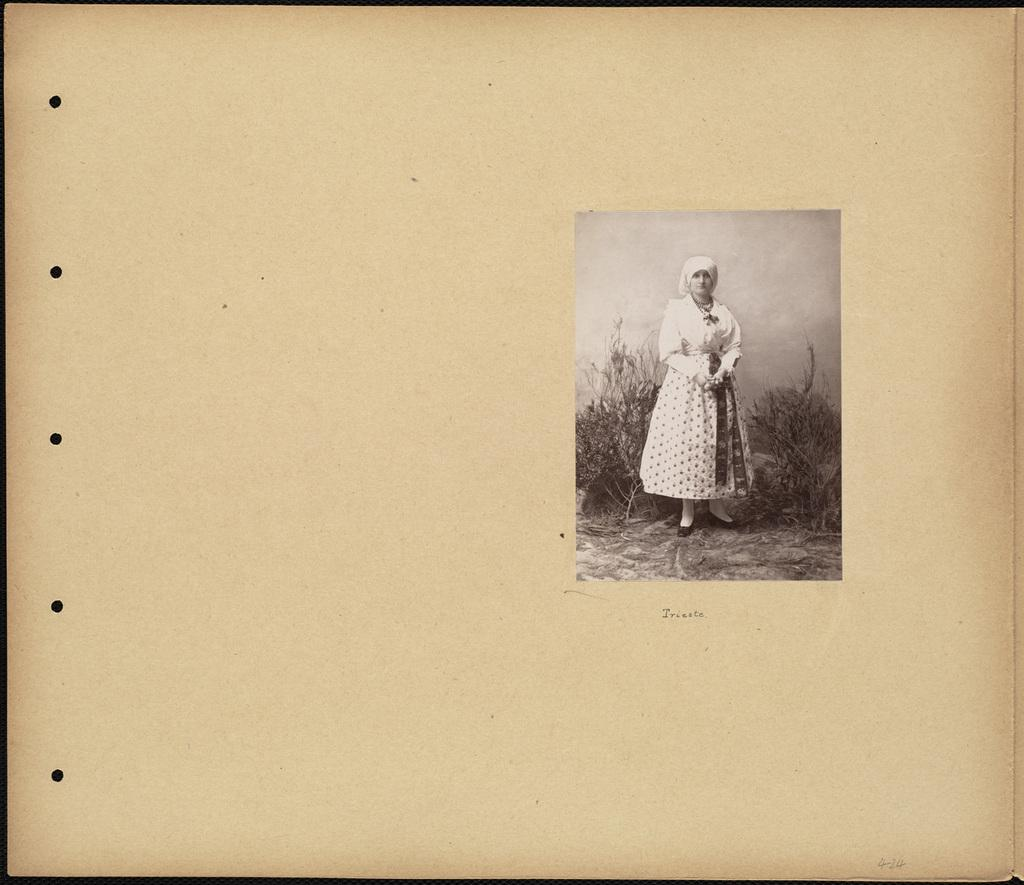What is present in the image that contains visuals and information? There is a poster in the image that contains images and text. Can you describe the content of the poster? The poster contains images and text, but the specific content cannot be determined from the provided facts. How many beds are visible in the image? There are no beds present in the image; it only contains a poster with images and text. Is there a rat hiding behind the text on the poster? There is no mention of a rat in the image, and therefore it cannot be determined if one is present. 